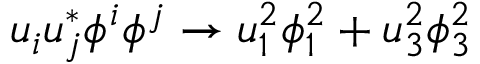Convert formula to latex. <formula><loc_0><loc_0><loc_500><loc_500>u _ { i } u _ { j } ^ { * } \phi ^ { i } \phi ^ { j } \rightarrow u _ { 1 } ^ { 2 } \phi _ { 1 } ^ { 2 } + u _ { 3 } ^ { 2 } \phi _ { 3 } ^ { 2 }</formula> 